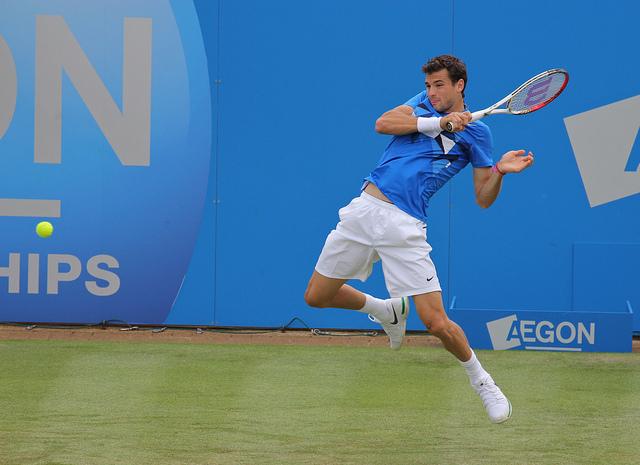What colors is the man wearing?
Give a very brief answer. Blue and white. What game is this man playing?
Write a very short answer. Tennis. Did the man hit the ball?
Be succinct. Yes. 